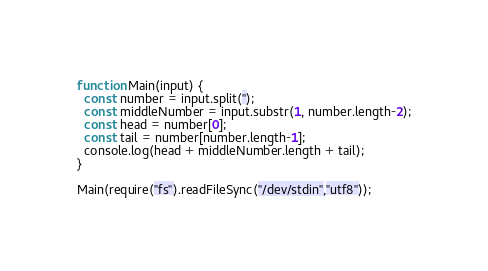Convert code to text. <code><loc_0><loc_0><loc_500><loc_500><_JavaScript_>function Main(input) {
  const number = input.split('');
  const middleNumber = input.substr(1, number.length-2);
  const head = number[0];
  const tail = number[number.length-1];
  console.log(head + middleNumber.length + tail);
}

Main(require("fs").readFileSync("/dev/stdin","utf8"));
</code> 